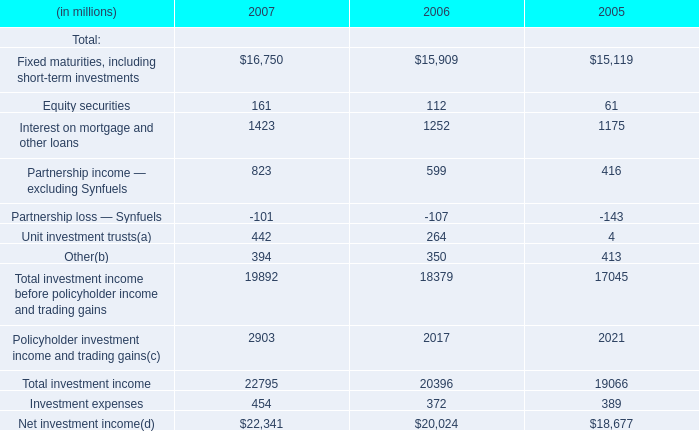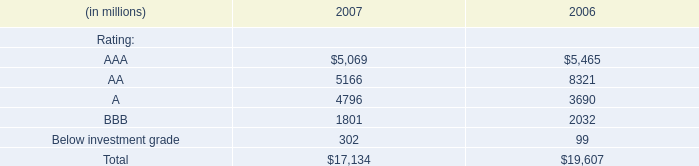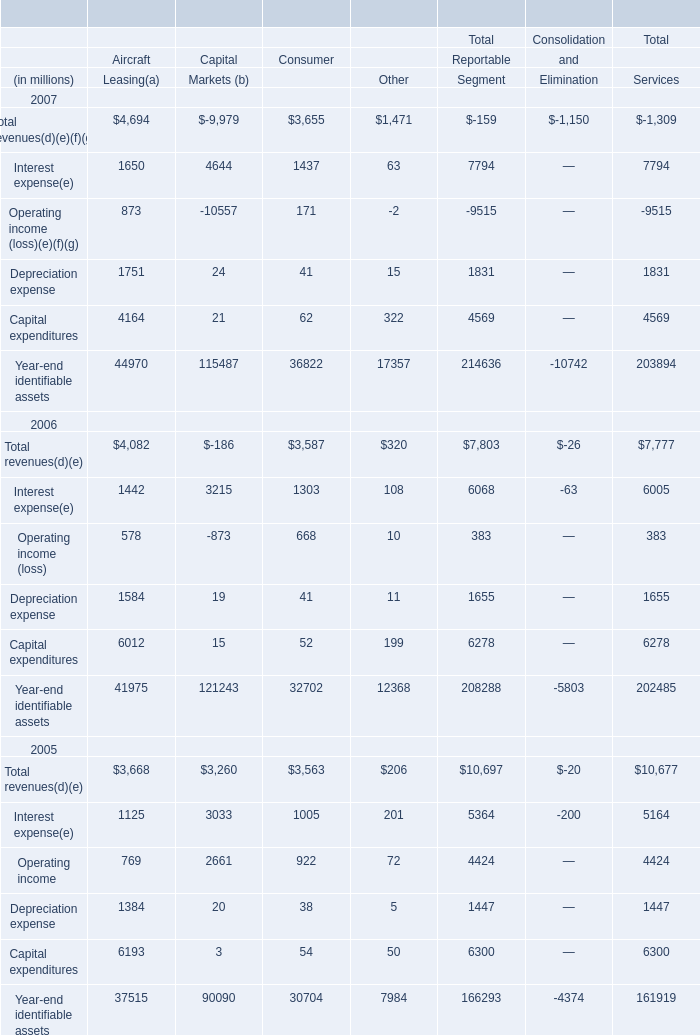What is the sum of AAA rating in 2007 and Interest expense for Leasing in 2007 ?( (in million) 
Computations: (1650 + 5069)
Answer: 6719.0. 